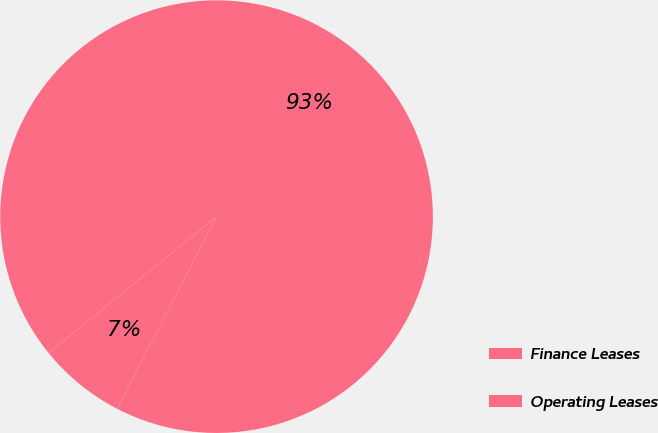Convert chart to OTSL. <chart><loc_0><loc_0><loc_500><loc_500><pie_chart><fcel>Finance Leases<fcel>Operating Leases<nl><fcel>93.46%<fcel>6.54%<nl></chart> 